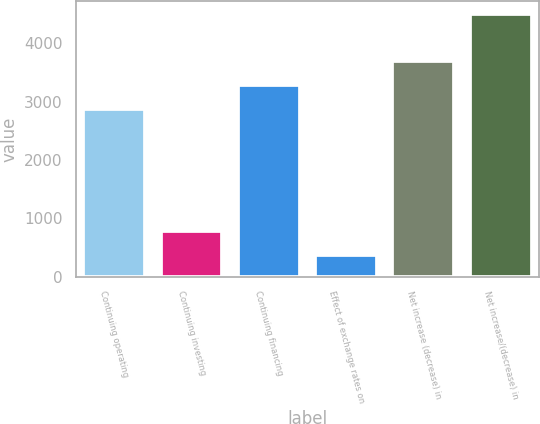Convert chart. <chart><loc_0><loc_0><loc_500><loc_500><bar_chart><fcel>Continuing operating<fcel>Continuing investing<fcel>Continuing financing<fcel>Effect of exchange rates on<fcel>Net increase (decrease) in<fcel>Net increase/(decrease) in<nl><fcel>2877<fcel>777.2<fcel>3290.2<fcel>364<fcel>3703.4<fcel>4496<nl></chart> 